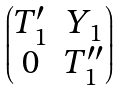Convert formula to latex. <formula><loc_0><loc_0><loc_500><loc_500>\begin{pmatrix} T _ { 1 } ^ { \prime } & { Y _ { 1 } } \\ 0 & T _ { 1 } ^ { \prime \prime } \end{pmatrix}</formula> 